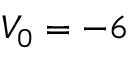<formula> <loc_0><loc_0><loc_500><loc_500>V _ { 0 } = - 6</formula> 